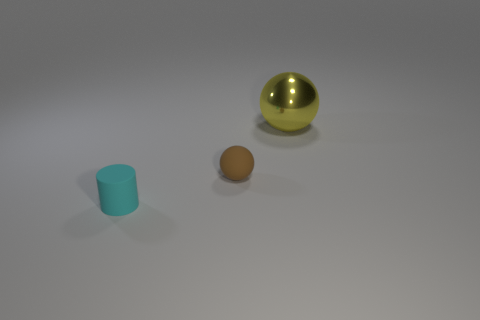Is the number of large shiny spheres that are left of the yellow ball greater than the number of small cylinders? no 